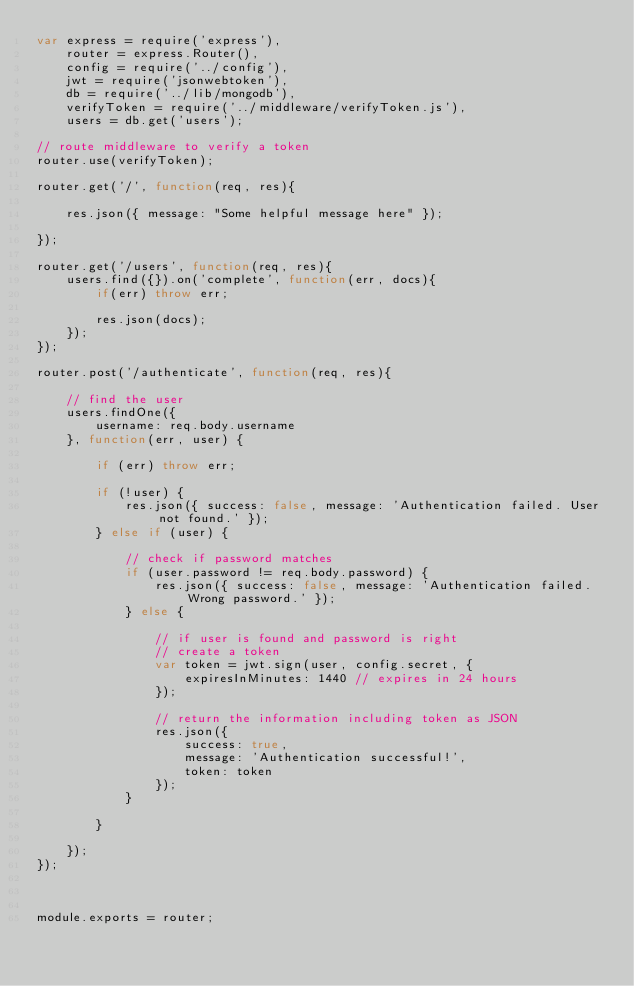<code> <loc_0><loc_0><loc_500><loc_500><_JavaScript_>var express = require('express'),
    router = express.Router(),
    config = require('../config'),
    jwt = require('jsonwebtoken'),
    db = require('../lib/mongodb'),
    verifyToken = require('../middleware/verifyToken.js'),
    users = db.get('users');
    
// route middleware to verify a token
router.use(verifyToken);

router.get('/', function(req, res){
    
    res.json({ message: "Some helpful message here" });
    
});

router.get('/users', function(req, res){
    users.find({}).on('complete', function(err, docs){
        if(err) throw err;

        res.json(docs);
    });
});

router.post('/authenticate', function(req, res){

    // find the user
    users.findOne({
        username: req.body.username
    }, function(err, user) {

        if (err) throw err;

        if (!user) {
            res.json({ success: false, message: 'Authentication failed. User not found.' });
        } else if (user) {

            // check if password matches
            if (user.password != req.body.password) {
                res.json({ success: false, message: 'Authentication failed. Wrong password.' });
            } else {

                // if user is found and password is right
                // create a token
                var token = jwt.sign(user, config.secret, {
                    expiresInMinutes: 1440 // expires in 24 hours
                });

                // return the information including token as JSON
                res.json({
                    success: true,
                    message: 'Authentication successful!',
                    token: token
                });
            }   

        }

    });
});



module.exports = router;</code> 